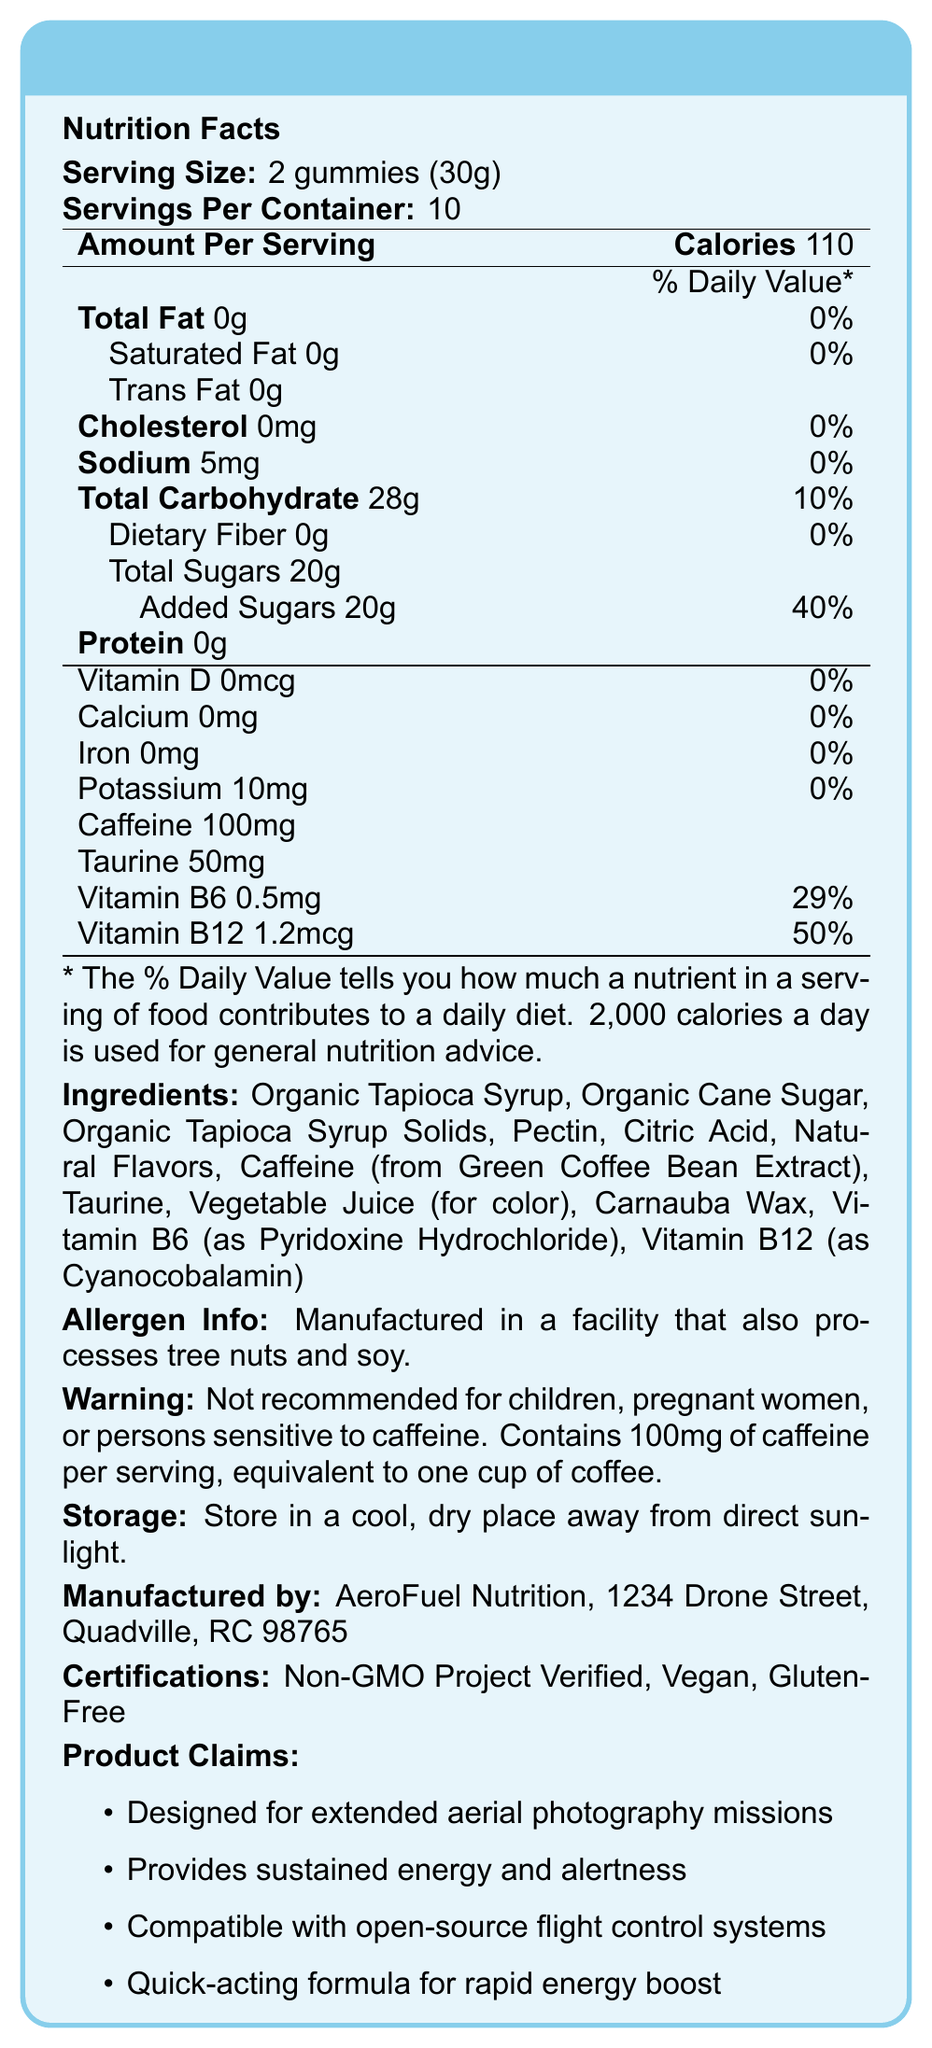who manufactures SkyShot Energy Gummies? According to the document, SkyShot Energy Gummies are manufactured by AeroFuel Nutrition, located at 1234 Drone Street, Quadville, RC 98765.
Answer: AeroFuel Nutrition what is the serving size of SkyShot Energy Gummies? The serving size information on the document indicates that one serving is equivalent to 2 gummies, which together weigh 30 grams.
Answer: 2 gummies (30g) how many calories does one serving of SkyShot Energy Gummies contain? The document's Nutrition Facts section states that one serving (2 gummies) contains 110 calories.
Answer: 110 what is the amount of caffeine per serving in SkyShot Energy Gummies? The Nutrition Facts section lists caffeine content as 100mg per serving.
Answer: 100mg what certifications do SkyShot Energy Gummies have? The certifications are listed in the document: Non-GMO Project Verified, Vegan, and Gluten-Free.
Answer: Non-GMO Project Verified, Vegan, Gluten-Free which ingredient is used for color in SkyShot Energy Gummies? A) Citrid Acid B) Organic Cane Sugar C) Vegetable Juice The ingredients list identifies "Vegetable Juice (for color)" as the ingredient used for coloring the gummies.
Answer: C) Vegetable Juice what percentage of Daily Value does the Vitamin B12 in one serving of SkyShot Energy Gummies provide? A) 29% B) 50% C) 59% D) 10% The document states that one serving provides 50% of the Daily Value for Vitamin B12.
Answer: B) 50% is the document's warning statement restricted to sensitivity to caffeine only? The warning statement also mentions that the product is not recommended for children, and pregnant women, in addition to those sensitive to caffeine.
Answer: No summarize the main idea of the document. The document is a detailed label for SkyShot Energy Gummies, which are formulated to assist with maintaining energy and alertness during long aerial photography sessions.
Answer: The document provides comprehensive information about SkyShot Energy Gummies, including their nutrition facts, ingredients, allergens, storage instructions, manufacturer information, certifications, and marketing claims. The gummies are designed to provide energy and alertness for extended aerial photography missions. how many servings are there per container of SkyShot Energy Gummies? The document lists that each container provides 10 servings.
Answer: 10 does SkyShot Energy Gummies contain any dietary fiber? The Nutrition Facts in the document list 0g of dietary fiber per serving.
Answer: No are SkyShot Energy Gummies suitable for children? The warning statement explicitly mentions that the product is not recommended for children.
Answer: No how might SkyShot Energy Gummies be beneficial during extended aerial photography missions? According to the marketing claims, SkyShot Energy Gummies are designed to provide sustained energy and alertness during such missions.
Answer: Provides sustained energy and alertness do SkyShot Energy Gummies contain any iron? The Nutrition Facts label indicates that there is 0mg of iron per serving.
Answer: No can you determine the price of SkyShot Energy Gummies from the document? The document does not provide any information about the price of SkyShot Energy Gummies.
Answer: Not enough information 